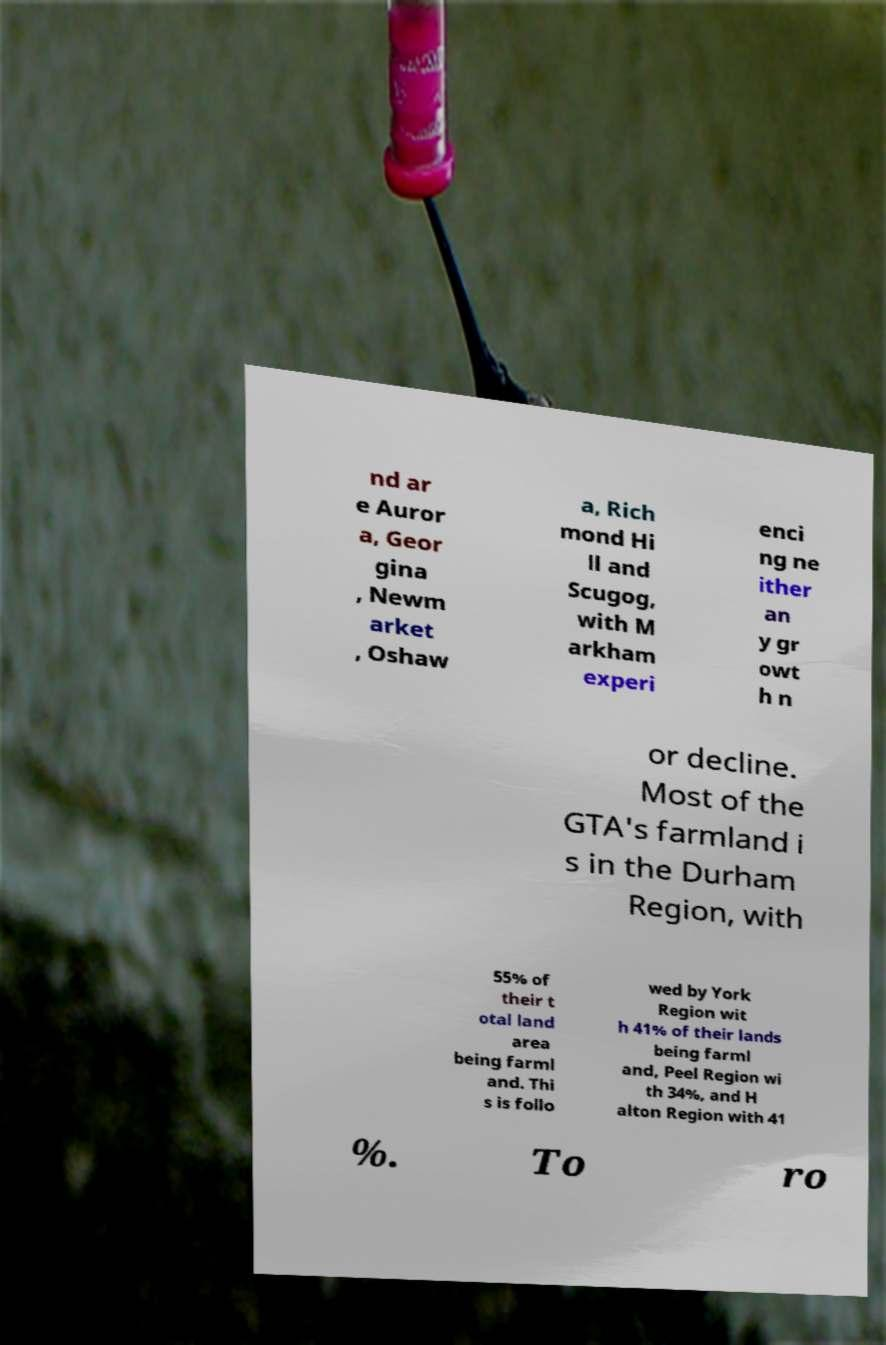Could you extract and type out the text from this image? nd ar e Auror a, Geor gina , Newm arket , Oshaw a, Rich mond Hi ll and Scugog, with M arkham experi enci ng ne ither an y gr owt h n or decline. Most of the GTA's farmland i s in the Durham Region, with 55% of their t otal land area being farml and. Thi s is follo wed by York Region wit h 41% of their lands being farml and, Peel Region wi th 34%, and H alton Region with 41 %. To ro 